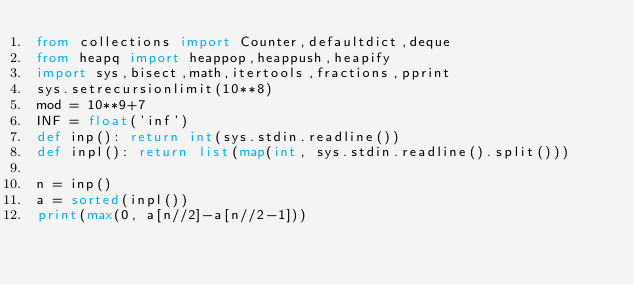<code> <loc_0><loc_0><loc_500><loc_500><_Python_>from collections import Counter,defaultdict,deque
from heapq import heappop,heappush,heapify
import sys,bisect,math,itertools,fractions,pprint
sys.setrecursionlimit(10**8)
mod = 10**9+7
INF = float('inf')
def inp(): return int(sys.stdin.readline())
def inpl(): return list(map(int, sys.stdin.readline().split()))

n = inp()
a = sorted(inpl())
print(max(0, a[n//2]-a[n//2-1]))</code> 